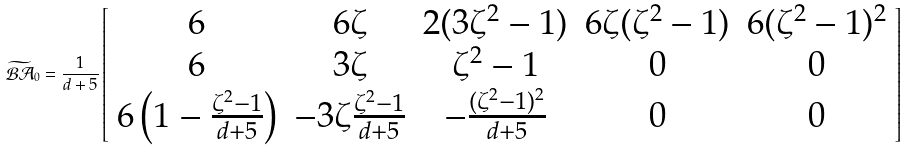Convert formula to latex. <formula><loc_0><loc_0><loc_500><loc_500>\widetilde { \mathcal { B A } } _ { 0 } = \frac { 1 } { d + 5 } \left [ \begin{array} { c c c c c } 6 & 6 \zeta & 2 ( 3 \zeta ^ { 2 } - 1 ) & 6 \zeta ( \zeta ^ { 2 } - 1 ) & 6 ( \zeta ^ { 2 } - 1 ) ^ { 2 } \\ 6 & 3 \zeta & \zeta ^ { 2 } - 1 & 0 & 0 \\ 6 \left ( 1 - \frac { \zeta ^ { 2 } - 1 } { d + 5 } \right ) & - 3 \zeta \frac { \zeta ^ { 2 } - 1 } { d + 5 } & - \frac { ( \zeta ^ { 2 } - 1 ) ^ { 2 } } { d + 5 } & 0 & 0 \end{array} \right ]</formula> 